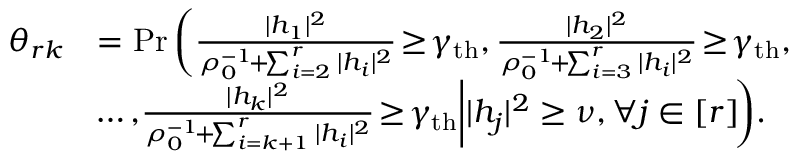<formula> <loc_0><loc_0><loc_500><loc_500>\begin{array} { r l } { \theta _ { r k } } & { = P r \left ( { \frac { | h _ { 1 } | ^ { 2 } } { \rho _ { 0 } ^ { - 1 } \, + \, \sum _ { i = 2 } ^ { r } | h _ { i } | ^ { 2 } } \, \geq \, \gamma _ { t h } , \frac { | h _ { 2 } | ^ { 2 } } { \rho _ { 0 } ^ { - 1 } \, + \, \sum _ { i = 3 } ^ { r } | h _ { i } | ^ { 2 } } \, \geq \, \gamma _ { t h } , } } \\ & { \, \dots , \, { \frac { | h _ { k } | ^ { 2 } } { \rho _ { 0 } ^ { - 1 } \, + \, \sum _ { i = k + 1 } ^ { r } | h _ { i } | ^ { 2 } } \, \geq \, \gamma _ { t h } \Big | | h _ { j } | ^ { 2 } \geq \nu , \forall j \in [ r ] \, } \right ) \, . } \end{array}</formula> 